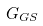<formula> <loc_0><loc_0><loc_500><loc_500>G _ { G S }</formula> 